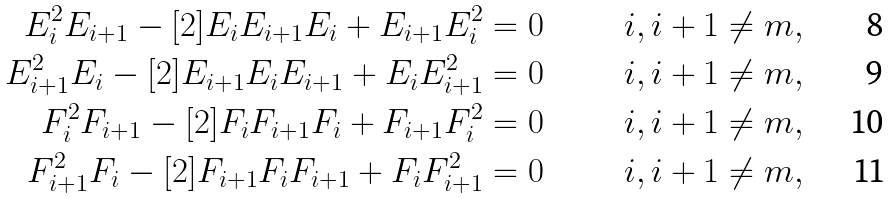<formula> <loc_0><loc_0><loc_500><loc_500>E _ { i } ^ { 2 } E _ { i + 1 } - [ 2 ] E _ { i } E _ { i + 1 } E _ { i } + E _ { i + 1 } E _ { i } ^ { 2 } & = 0 & i , i + 1 \neq m , \\ E _ { i + 1 } ^ { 2 } E _ { i } - [ 2 ] E _ { i + 1 } E _ { i } E _ { i + 1 } + E _ { i } E _ { i + 1 } ^ { 2 } & = 0 & i , i + 1 \neq m , \\ F _ { i } ^ { 2 } F _ { i + 1 } - [ 2 ] F _ { i } F _ { i + 1 } F _ { i } + F _ { i + 1 } F _ { i } ^ { 2 } & = 0 & i , i + 1 \neq m , \\ F _ { i + 1 } ^ { 2 } F _ { i } - [ 2 ] F _ { i + 1 } F _ { i } F _ { i + 1 } + F _ { i } F _ { i + 1 } ^ { 2 } & = 0 & i , i + 1 \neq m ,</formula> 